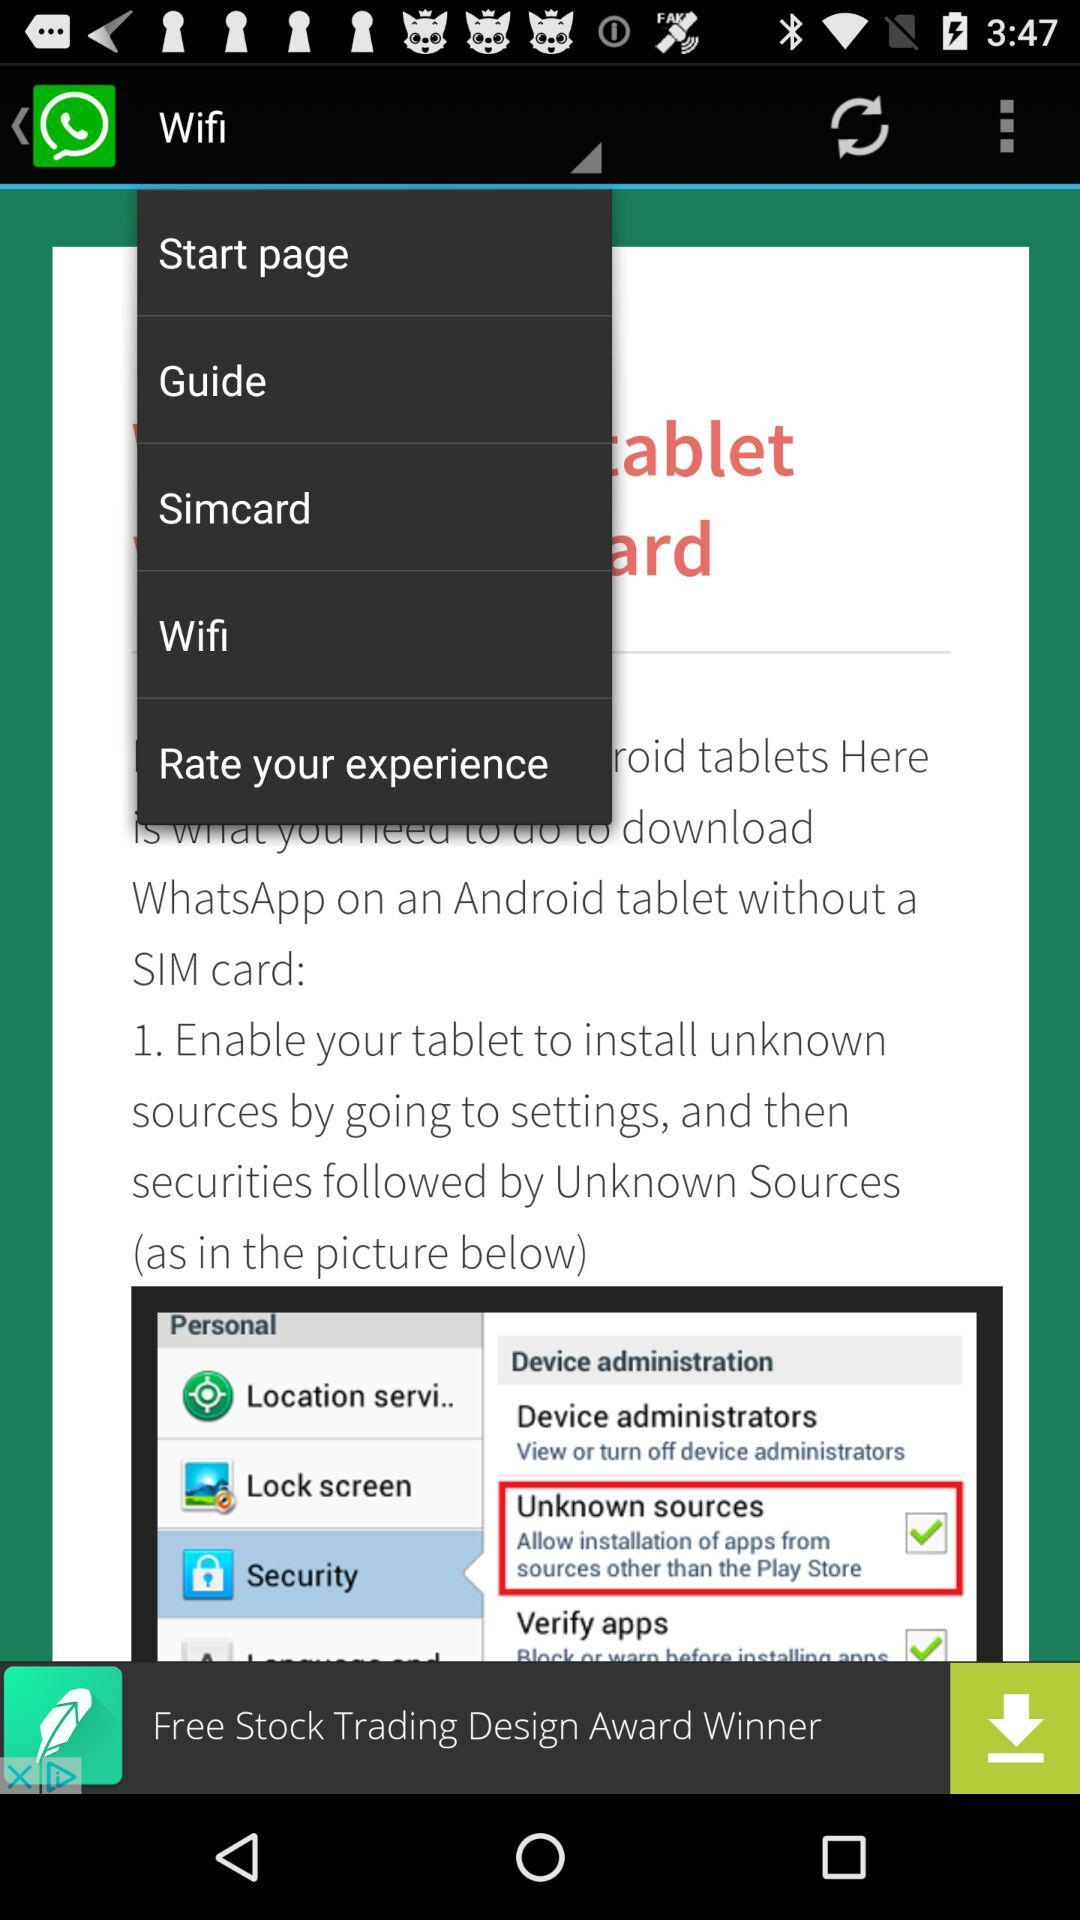Which option from the drop-down list is selected? The option that is selected from the drop-down list is "Wifi". 